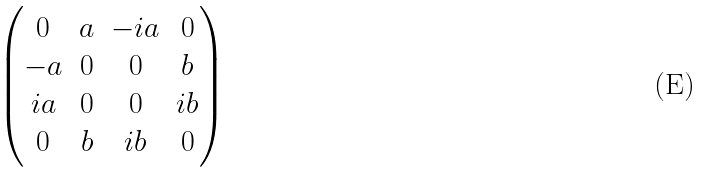Convert formula to latex. <formula><loc_0><loc_0><loc_500><loc_500>\begin{pmatrix} 0 & a & - i a & 0 \\ - a & 0 & 0 & b \\ i a & 0 & 0 & i b \\ 0 & b & i b & 0 \end{pmatrix}</formula> 